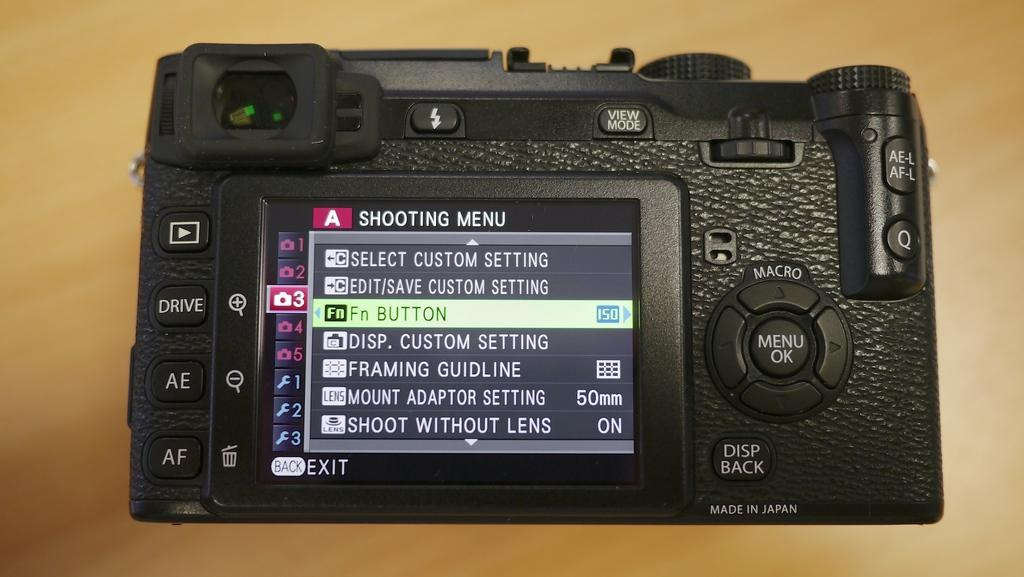What is the main object in the image? There is a camera on a platform in the image. What feature does the camera have? The camera has a screen. What can be seen on the screen of the camera? There is text and symbols visible on the screen. Are there any fairies playing in the basin near the camera in the image? There is no basin or fairies present in the image; it features a camera on a platform with a screen displaying text and symbols. 